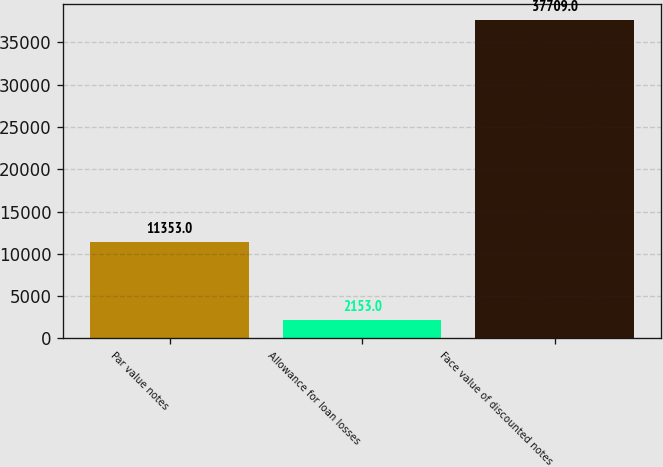Convert chart. <chart><loc_0><loc_0><loc_500><loc_500><bar_chart><fcel>Par value notes<fcel>Allowance for loan losses<fcel>Face value of discounted notes<nl><fcel>11353<fcel>2153<fcel>37709<nl></chart> 